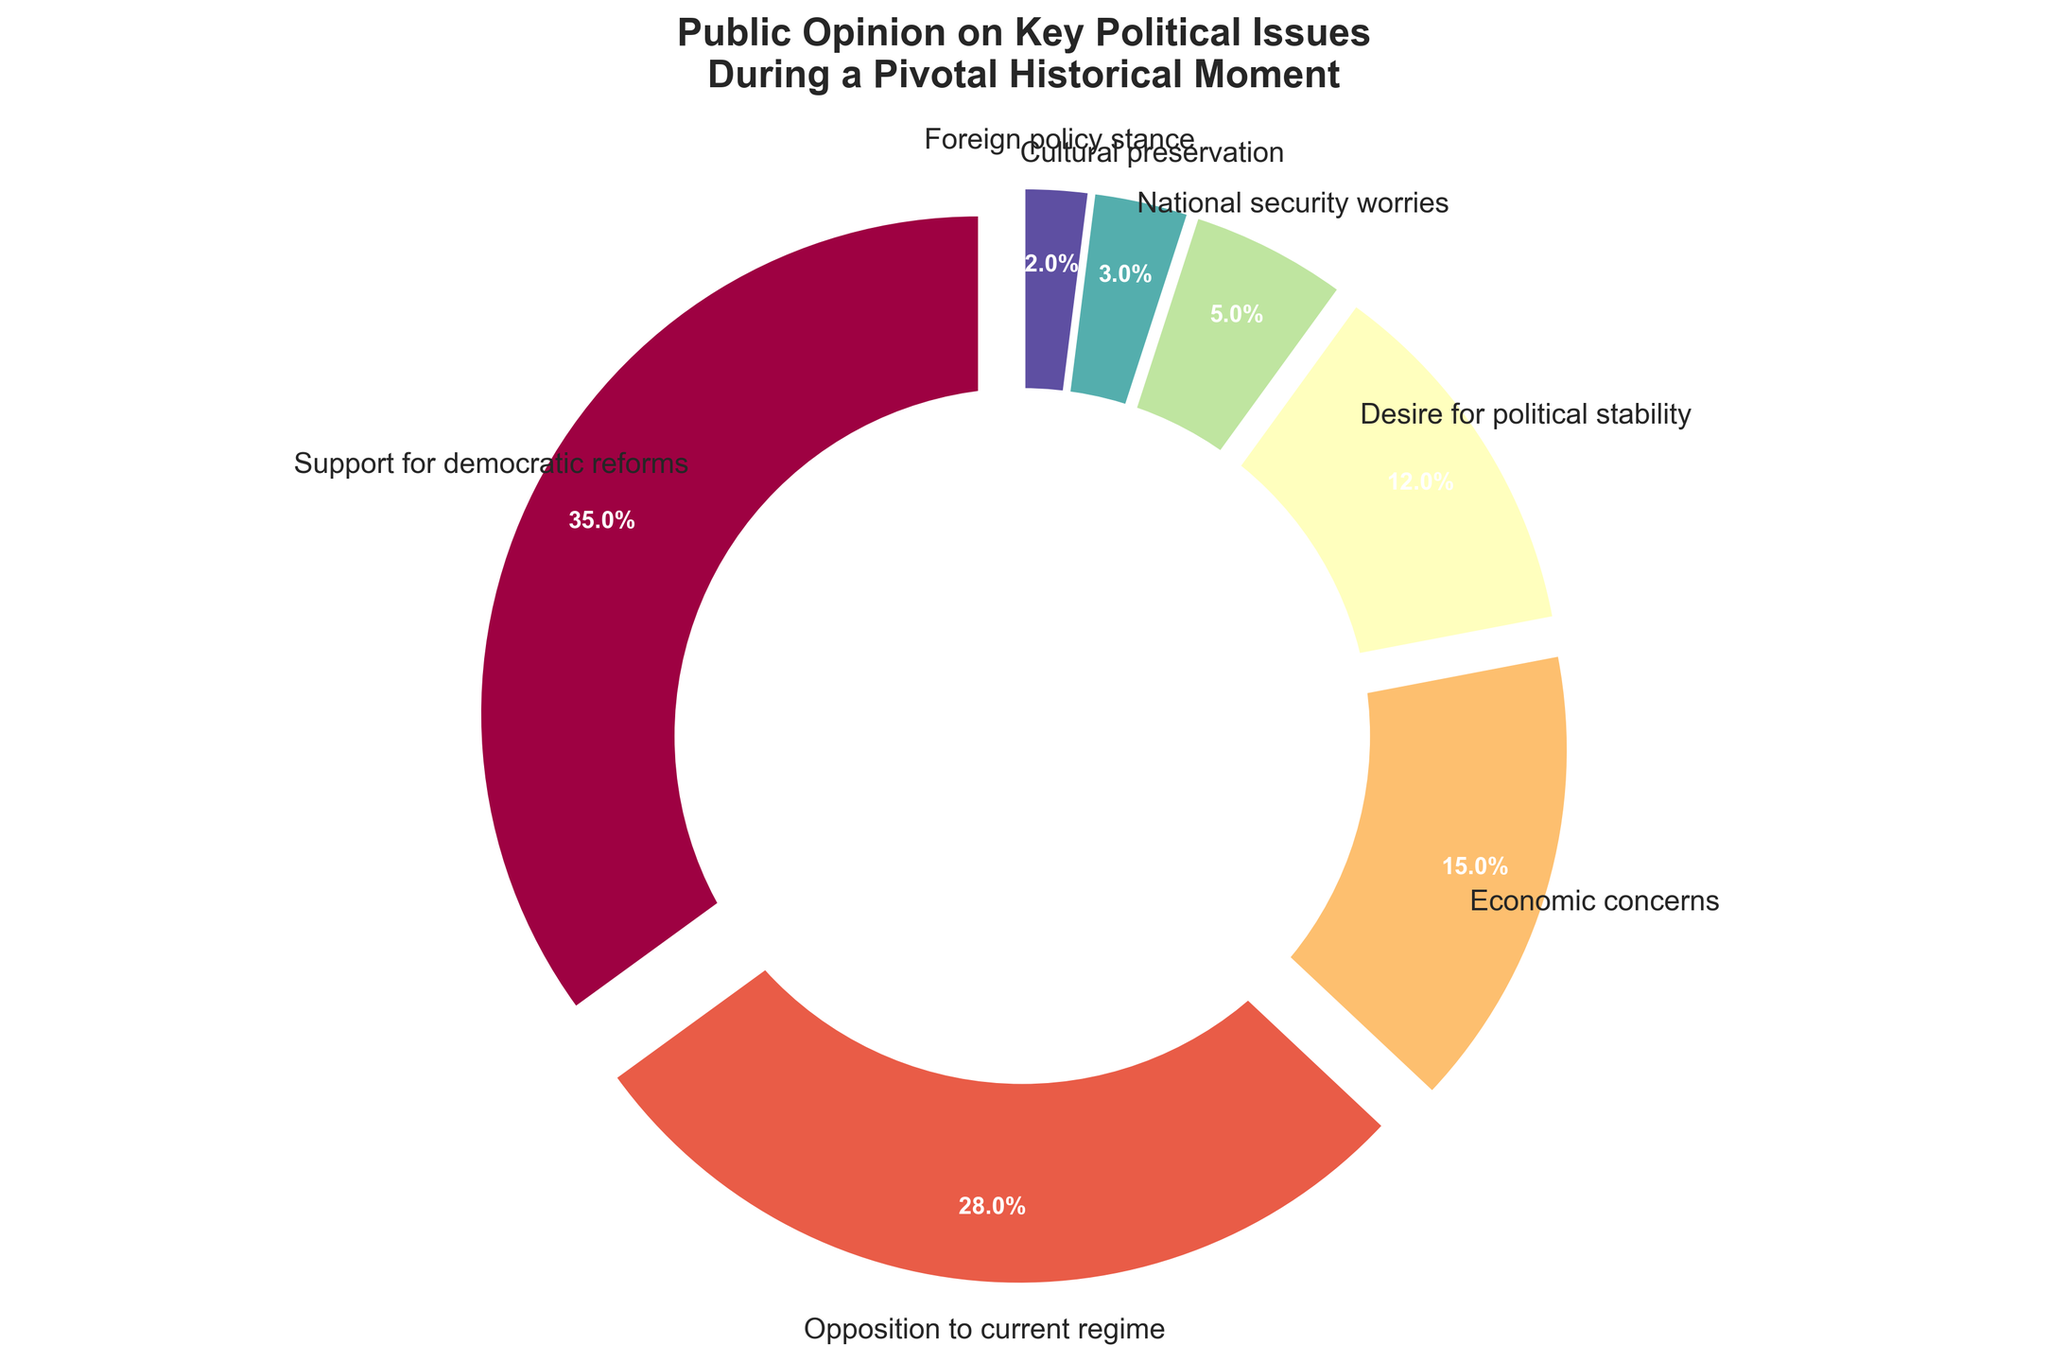What is the percentage of public opinion on economic concerns? We look at the pie chart segment labeled "Economic concerns" to find its percentage.
Answer: 15% Which issue has the highest percentage of public opinion? We examine the pie chart for the largest segment, which is labeled "Support for democratic reforms."
Answer: Support for democratic reforms How much greater is the percentage for opposition to the current regime than for desire for political stability? Compare the percentages for "Opposition to current regime" and "Desire for political stability" and subtract the latter from the former: 28% - 12% = 16%.
Answer: 16% What is the combined percentage for national security worries and cultural preservation? Sum the percentages for "National security worries" and "Cultural preservation": 5% + 3% = 8%.
Answer: 8% Which issue has the smallest percentage of public opinion, and what is that percentage? Identify the smallest segment in the pie chart, which corresponds to "Foreign policy stance," and note its percentage.
Answer: Foreign policy stance, 2% How does the percentage of people concerned with economic issues compare to those worried about national security? Compare the percentages for "Economic concerns" and "National security worries": 15% is greater than 5%.
Answer: Economic concerns are greater What is the percentage difference between support for democratic reforms and opposition to the current regime? Subtract the percentage of "Opposition to current regime" from "Support for democratic reforms": 35% - 28% = 7%.
Answer: 7% If we add the percentages of issues related to governance (support for democratic reforms and opposition to current regime), what is the total? Sum the percentages of "Support for democratic reforms" and "Opposition to current regime": 35% + 28% = 63%.
Answer: 63% What is the average percentage of public opinion for desire for political stability, national security worries, cultural preservation, and foreign policy stance? Sum the percentages of these issues and divide by the number of issues: (12% + 5% + 3% + 2%) / 4 = 22% / 4 = 5.5%.
Answer: 5.5% How do the colors represent the different public opinion issues in the pie chart? Describe the various colors used in the pie chart segments, noting which colors correspond to which issues. E.g., a particular shade of color is used for each specific issue to help distinguish different segments visually.
Answer: Colors correspond to specific issues (no exact colors specified) 